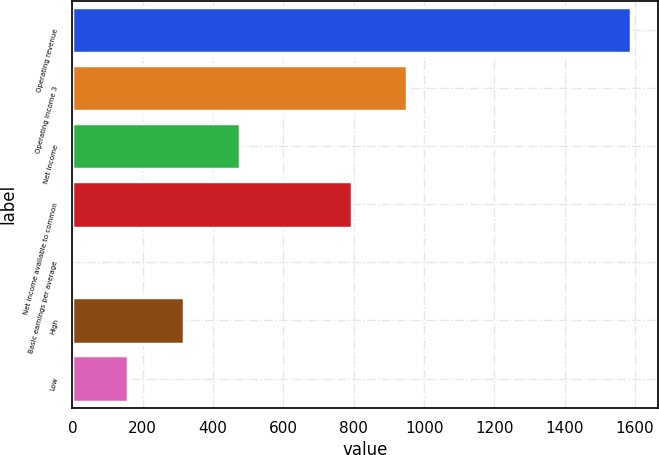<chart> <loc_0><loc_0><loc_500><loc_500><bar_chart><fcel>Operating revenue<fcel>Operating income 3<fcel>Net income<fcel>Net income available to common<fcel>Basic earnings per average<fcel>High<fcel>Low<nl><fcel>1587<fcel>952.45<fcel>476.56<fcel>793.82<fcel>0.67<fcel>317.93<fcel>159.3<nl></chart> 